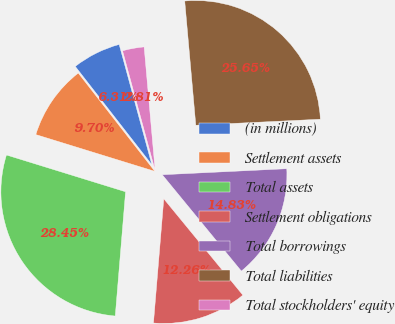<chart> <loc_0><loc_0><loc_500><loc_500><pie_chart><fcel>(in millions)<fcel>Settlement assets<fcel>Total assets<fcel>Settlement obligations<fcel>Total borrowings<fcel>Total liabilities<fcel>Total stockholders' equity<nl><fcel>6.31%<fcel>9.7%<fcel>28.45%<fcel>12.26%<fcel>14.83%<fcel>25.65%<fcel>2.81%<nl></chart> 